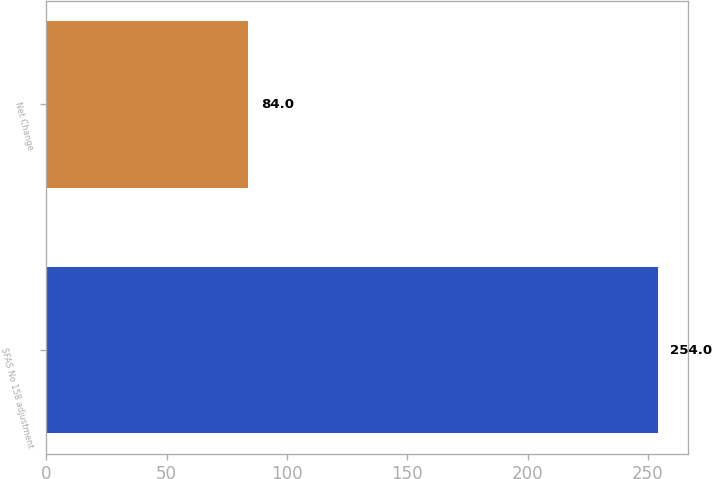Convert chart. <chart><loc_0><loc_0><loc_500><loc_500><bar_chart><fcel>SFAS No 158 adjustment<fcel>Net Change<nl><fcel>254<fcel>84<nl></chart> 